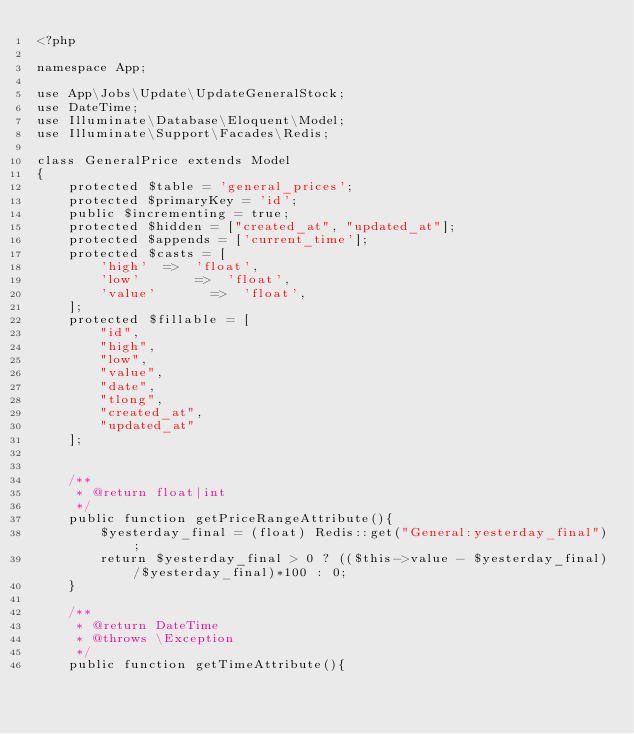Convert code to text. <code><loc_0><loc_0><loc_500><loc_500><_PHP_><?php

namespace App;

use App\Jobs\Update\UpdateGeneralStock;
use DateTime;
use Illuminate\Database\Eloquent\Model;
use Illuminate\Support\Facades\Redis;

class GeneralPrice extends Model
{
    protected $table = 'general_prices';
    protected $primaryKey = 'id';
    public $incrementing = true;
    protected $hidden = ["created_at", "updated_at"];
    protected $appends = ['current_time'];
    protected $casts = [
        'high'  =>  'float',
        'low'       =>  'float',
        'value'       =>  'float',
    ];
    protected $fillable = [
        "id",
        "high",
        "low",
        "value",
        "date",
        "tlong",
        "created_at",
        "updated_at"
    ];


    /**
     * @return float|int
     */
    public function getPriceRangeAttribute(){
        $yesterday_final = (float) Redis::get("General:yesterday_final");
        return $yesterday_final > 0 ? (($this->value - $yesterday_final)/$yesterday_final)*100 : 0;
    }

    /**
     * @return DateTime
     * @throws \Exception
     */
    public function getTimeAttribute(){</code> 